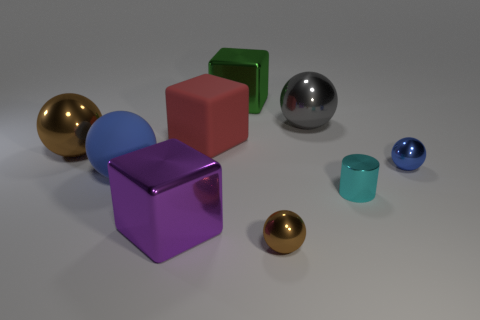The other matte object that is the same shape as the gray thing is what color?
Your answer should be compact. Blue. What material is the brown thing on the right side of the large ball that is in front of the small blue metal sphere?
Make the answer very short. Metal. There is a tiny thing that is behind the cyan object; does it have the same shape as the gray thing that is right of the big rubber block?
Offer a very short reply. Yes. How big is the metallic thing that is behind the small brown object and in front of the cyan metal cylinder?
Your response must be concise. Large. How many other objects are there of the same color as the tiny shiny cylinder?
Your answer should be very brief. 0. Does the sphere behind the large brown shiny object have the same material as the purple object?
Your response must be concise. Yes. Is the number of big blue matte objects to the right of the large purple object less than the number of small metal balls on the right side of the tiny blue sphere?
Offer a terse response. No. Is there anything else that is the same shape as the tiny cyan object?
Provide a short and direct response. No. There is a tiny thing that is the same color as the rubber ball; what material is it?
Your answer should be very brief. Metal. How many small brown shiny spheres are behind the cube behind the large rubber object that is behind the big blue rubber sphere?
Give a very brief answer. 0. 